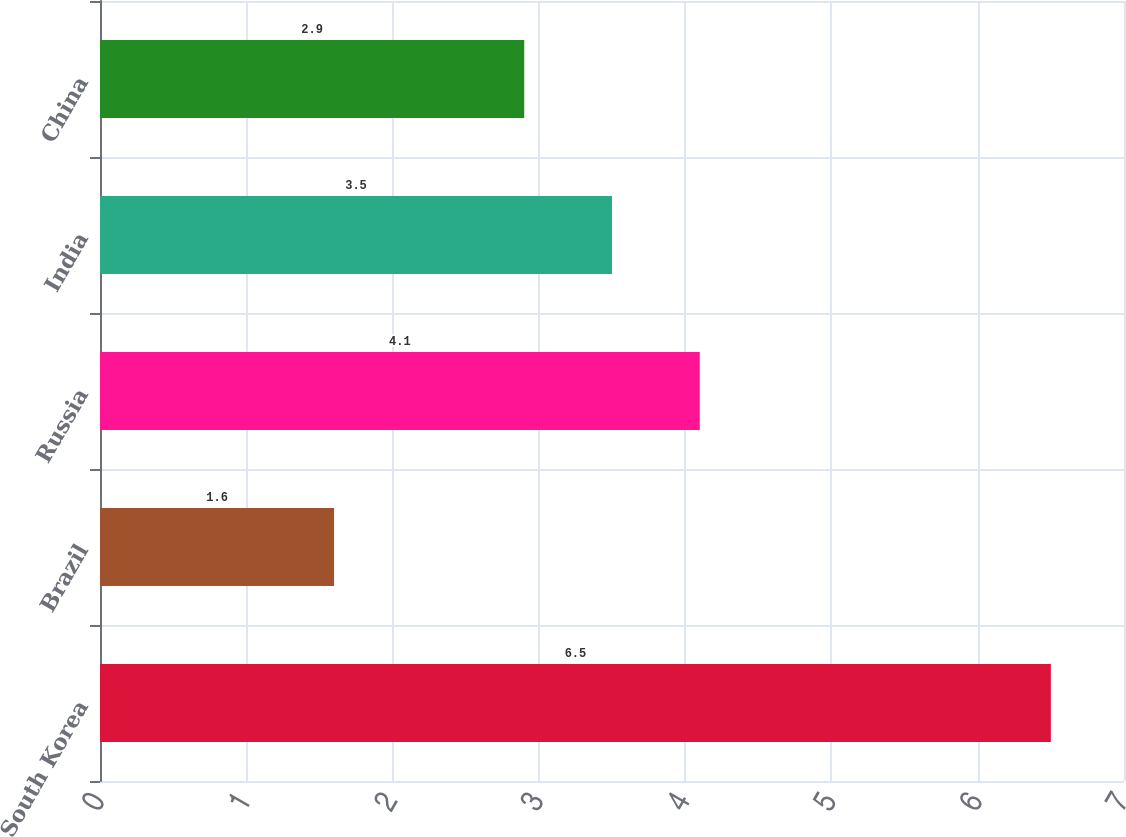Convert chart. <chart><loc_0><loc_0><loc_500><loc_500><bar_chart><fcel>South Korea<fcel>Brazil<fcel>Russia<fcel>India<fcel>China<nl><fcel>6.5<fcel>1.6<fcel>4.1<fcel>3.5<fcel>2.9<nl></chart> 